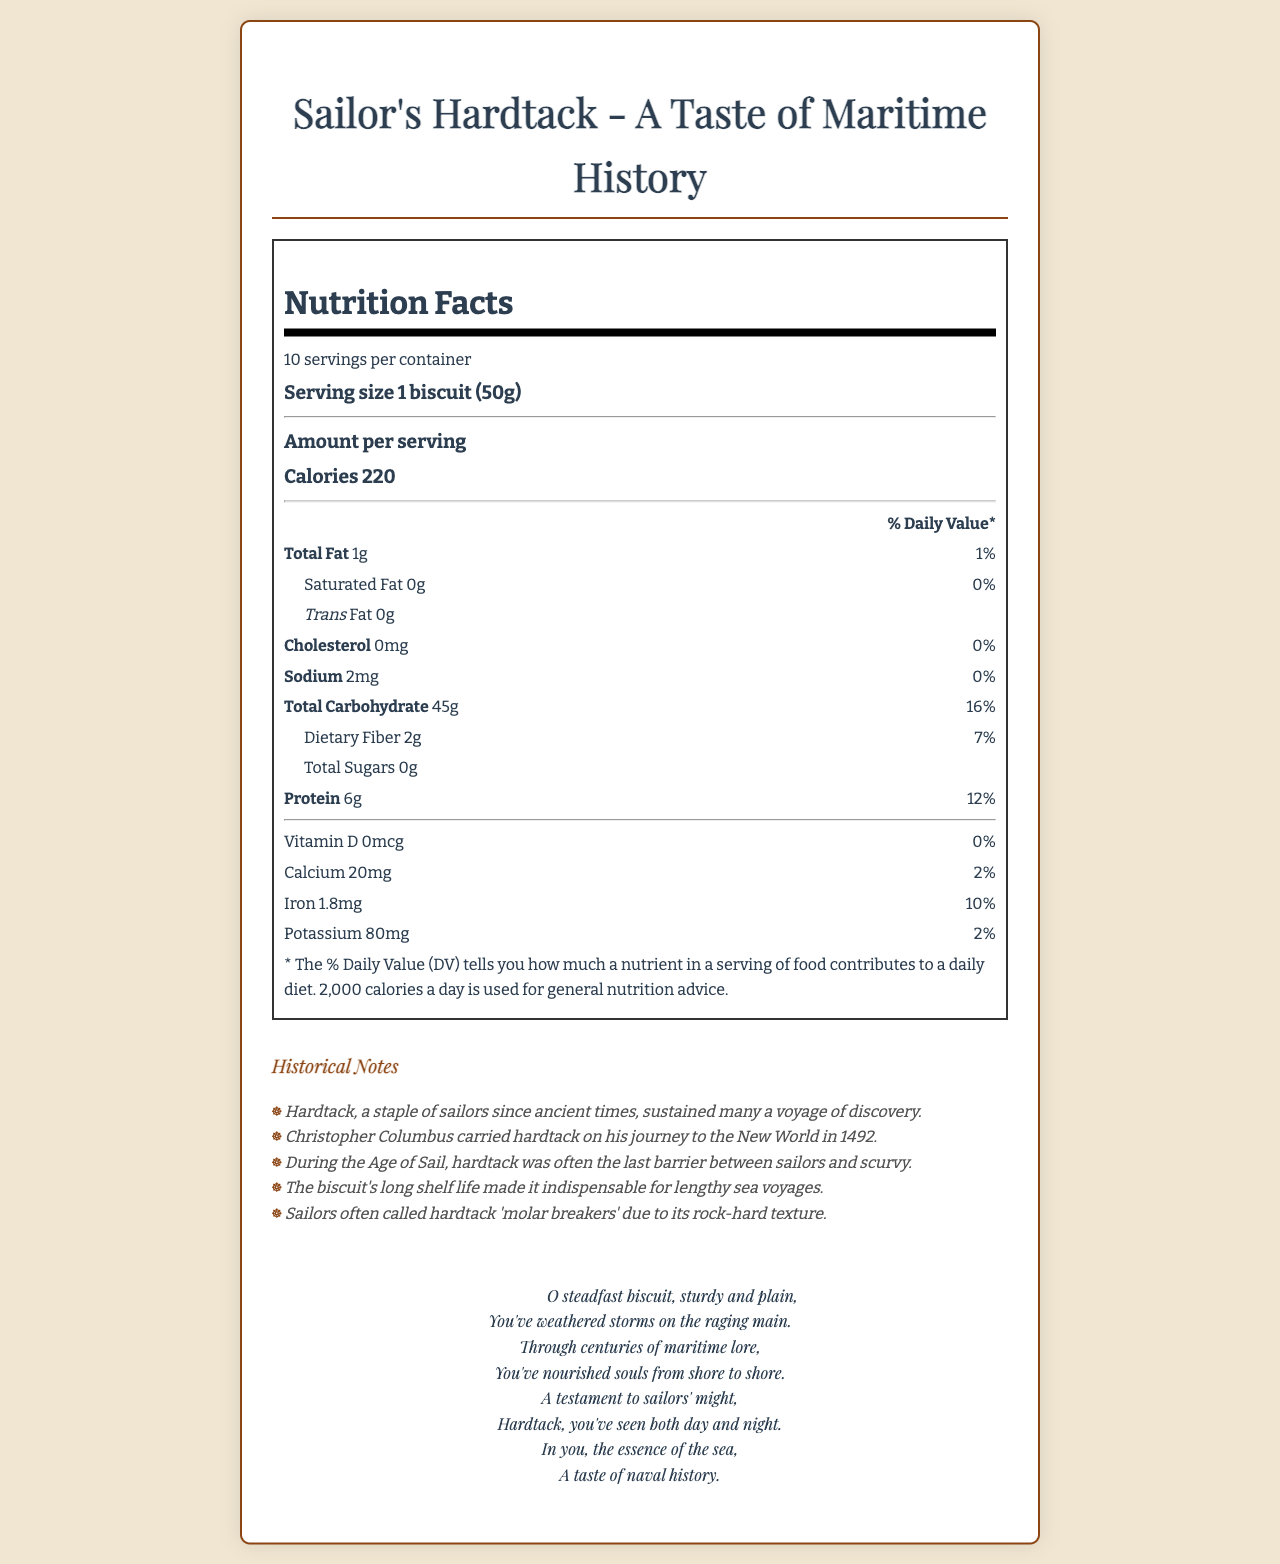What is the serving size of Sailor's Hardtack? The document states that the serving size is 1 biscuit which weighs 50 grams.
Answer: 1 biscuit (50g) How many calories are there per serving of the hardtack? The document lists 220 calories per serving.
Answer: 220 What percentage of the daily value is the total fat content per serving? The total fat content per serving is 1 gram, which is 1% of the daily value.
Answer: 1% How many servings does the container hold? The document specifies that the container holds 10 servings.
Answer: 10 What are some of the historical uses of hardtack mentioned in the document? The historical notes highlight how hardtack sustained many voyages, was carried by Columbus, and was vital in preventing scurvy.
Answer: Used during long sea voyages, carried by Christopher Columbus, and helped prevent scurvy among sailors. Is there any trans fat in Sailor's Hardtack? The document mentions 0 grams of trans fat per serving.
Answer: No What is the amount of dietary fiber in one serving? A. 0g B. 2g C. 4g D. 6g The document shows that each serving contains 2 grams of dietary fiber.
Answer: B Which nutrient has a daily value percentage of 12% per serving? A. Calcium B. Iron C. Sodium D. Protein Protein has a daily value percentage of 12% per serving as indicated in the document.
Answer: D Does the hardtack contain cholesterol? The document indicates 0 milligrams of cholesterol per serving with a daily value of 0%.
Answer: No Summarize the main idea of the document. The document serves a dual purpose: informing readers about the nutritional composition of hardtack and celebrating its role in maritime history, combining factual data with cultural significance.
Answer: The document provides the nutritional content of Sailor's Hardtack, a historical staple for sailors, detailing its calorie count, fat content, and other nutritional information. It also includes historical notes on its use during maritime voyages and a poetic reflection celebrating its significance. How many milligrams of potassium are there in a serving? The nutritional label lists 80 milligrams of potassium per serving.
Answer: 80mg What percentage of the daily value for iron does one serving of hardtack provide? The document states that one serving provides 10% of the daily value for iron.
Answer: 10% What is the poetic reflection celebrating? The poetic reflection praises the hardtack, acknowledging its steadfast presence through centuries of sea voyages and its importance to sailors.
Answer: The essence and significance of hardtack in maritime history and its role in nourishing sailors over centuries. Does hardtack help prevent modern dietary deficiencies? The document mentions its historical role in preventing scurvy, but it does not provide information on modern nutritional deficiencies or how hardtack might help prevent them.
Answer: Not enough information What is the total carbohydrate content per serving? The document indicates that each serving contains 45 grams of total carbohydrates.
Answer: 45g What is the general tone of the poetic reflection included in the document? The poetic reflection is rich with emotion, celebrating the historical and cultural significance of hardtack with a sentimental view of its role in maritime history.
Answer: Sentimental and celebratory 